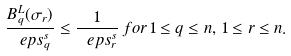<formula> <loc_0><loc_0><loc_500><loc_500>\frac { B _ { q } ^ { L } ( \sigma _ { r } ) } { \ e p s _ { q } ^ { s } } \leq \frac { 1 } { \ e p s _ { r } ^ { s } } \, f o r \, 1 \leq q \leq n , \, 1 \leq r \leq n .</formula> 